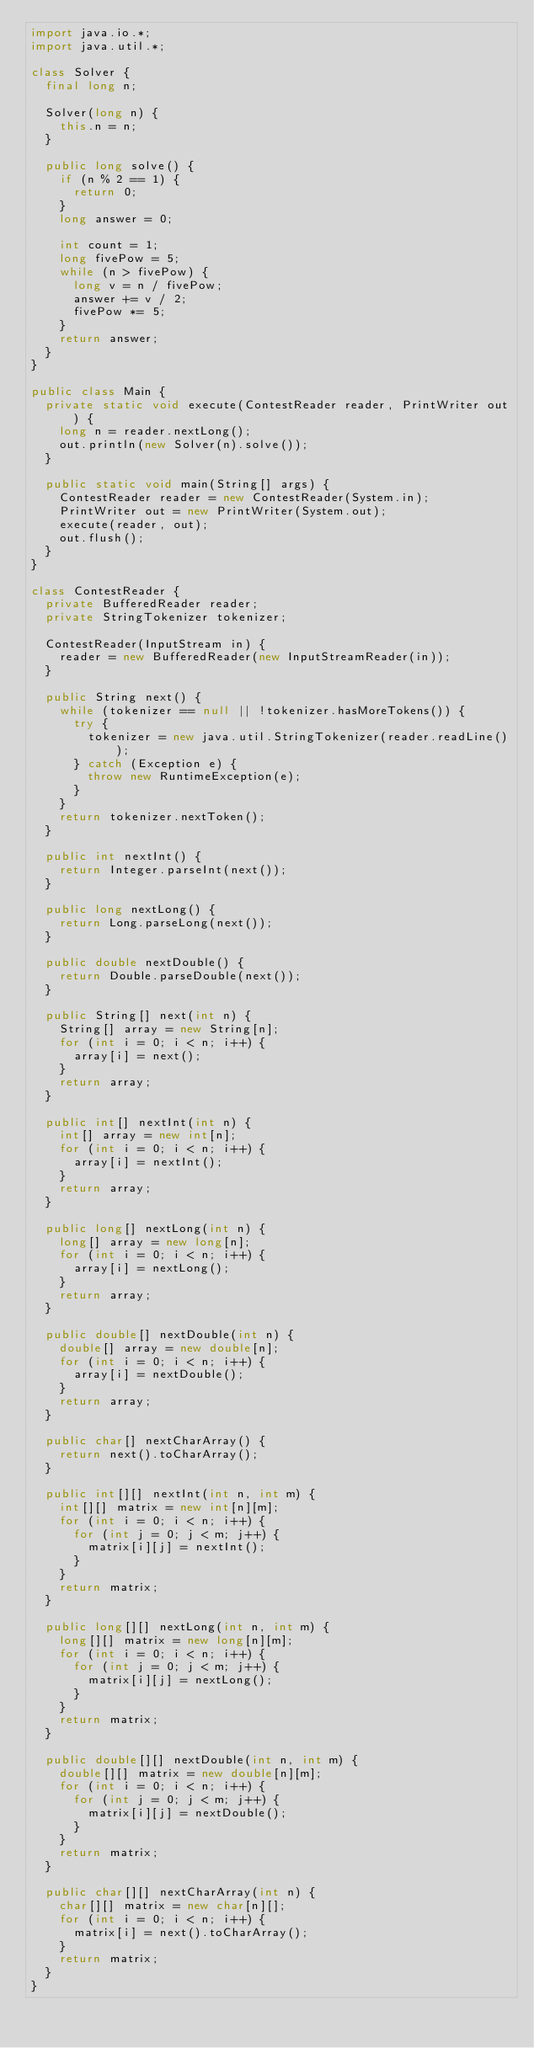Convert code to text. <code><loc_0><loc_0><loc_500><loc_500><_Java_>import java.io.*;
import java.util.*;

class Solver {
  final long n;
  
  Solver(long n) {
    this.n = n;
  }
  
  public long solve() {
    if (n % 2 == 1) {
      return 0;
    }
    long answer = 0;
    
    int count = 1;
    long fivePow = 5;
    while (n > fivePow) {
      long v = n / fivePow;
      answer += v / 2;
      fivePow *= 5;
    }
    return answer;
  }
}

public class Main {
  private static void execute(ContestReader reader, PrintWriter out) {
    long n = reader.nextLong();
    out.println(new Solver(n).solve());
  }
  
  public static void main(String[] args) {
    ContestReader reader = new ContestReader(System.in);
    PrintWriter out = new PrintWriter(System.out);
    execute(reader, out);
    out.flush();
  }
}

class ContestReader {
  private BufferedReader reader;
  private StringTokenizer tokenizer;
  
  ContestReader(InputStream in) {
    reader = new BufferedReader(new InputStreamReader(in));
  }
  
  public String next() {
    while (tokenizer == null || !tokenizer.hasMoreTokens()) {
      try {
        tokenizer = new java.util.StringTokenizer(reader.readLine());
      } catch (Exception e) {
        throw new RuntimeException(e);
      }
    }
    return tokenizer.nextToken();
  }
  
  public int nextInt() {
    return Integer.parseInt(next());
  }
  
  public long nextLong() {
    return Long.parseLong(next());
  }
  
  public double nextDouble() {
    return Double.parseDouble(next());
  }
  
  public String[] next(int n) {
    String[] array = new String[n];
    for (int i = 0; i < n; i++) {
      array[i] = next();
    }
    return array;
  }
  
  public int[] nextInt(int n) {
    int[] array = new int[n];
    for (int i = 0; i < n; i++) {
      array[i] = nextInt();
    }
    return array;
  }
  
  public long[] nextLong(int n) {
    long[] array = new long[n];
    for (int i = 0; i < n; i++) {
      array[i] = nextLong();
    }
    return array;
  }
  
  public double[] nextDouble(int n) {
    double[] array = new double[n];
    for (int i = 0; i < n; i++) {
      array[i] = nextDouble();
    }
    return array;
  }
  
  public char[] nextCharArray() {
    return next().toCharArray();
  }
  
  public int[][] nextInt(int n, int m) {
    int[][] matrix = new int[n][m];
    for (int i = 0; i < n; i++) {
      for (int j = 0; j < m; j++) {
        matrix[i][j] = nextInt();
      }
    }
    return matrix;
  }
  
  public long[][] nextLong(int n, int m) {
    long[][] matrix = new long[n][m];
    for (int i = 0; i < n; i++) {
      for (int j = 0; j < m; j++) {
        matrix[i][j] = nextLong();
      }
    }
    return matrix;
  }
  
  public double[][] nextDouble(int n, int m) {
    double[][] matrix = new double[n][m];
    for (int i = 0; i < n; i++) {
      for (int j = 0; j < m; j++) {
        matrix[i][j] = nextDouble();
      }
    }
    return matrix;
  }
  
  public char[][] nextCharArray(int n) {
    char[][] matrix = new char[n][];
    for (int i = 0; i < n; i++) {
      matrix[i] = next().toCharArray();
    }
    return matrix;
  }
}
</code> 